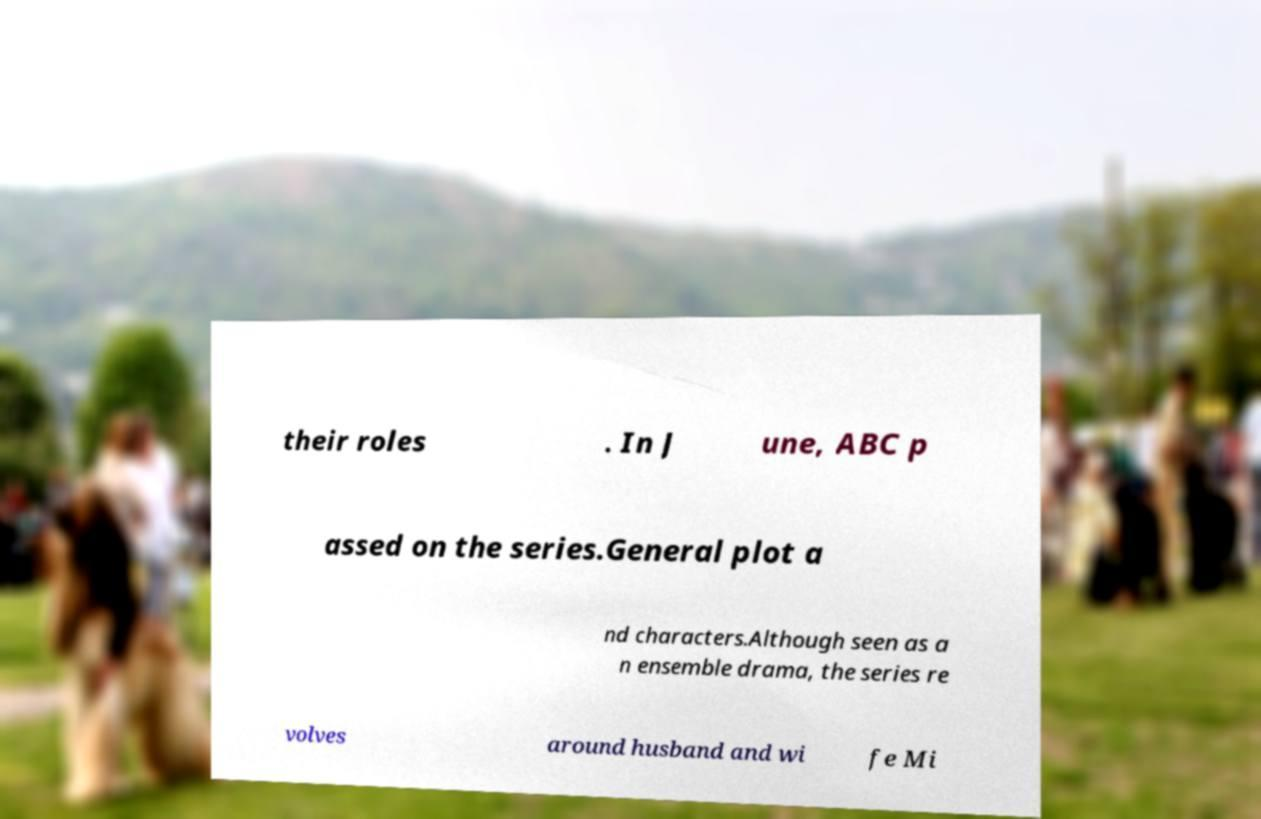What messages or text are displayed in this image? I need them in a readable, typed format. their roles . In J une, ABC p assed on the series.General plot a nd characters.Although seen as a n ensemble drama, the series re volves around husband and wi fe Mi 